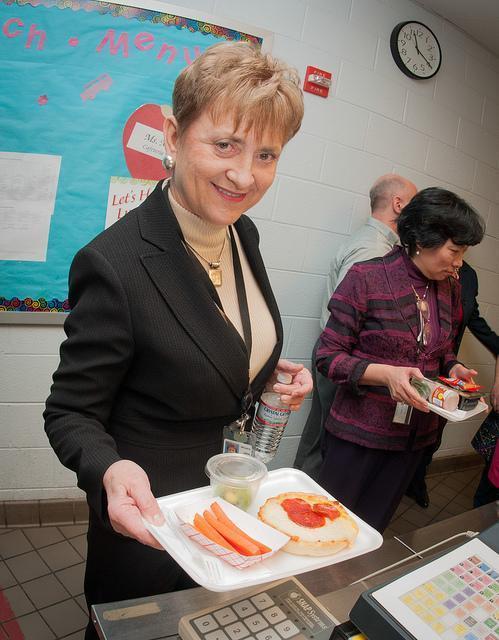How many dining tables can be seen?
Give a very brief answer. 1. How many people are in the photo?
Give a very brief answer. 3. How many bottles can you see?
Give a very brief answer. 1. 